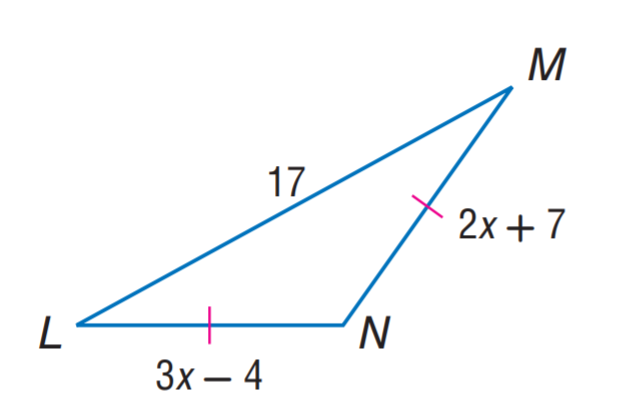Question: Find M N.
Choices:
A. 11
B. 15
C. 17
D. 29
Answer with the letter. Answer: D Question: Find L N.
Choices:
A. 11
B. 15
C. 17
D. 29
Answer with the letter. Answer: D 